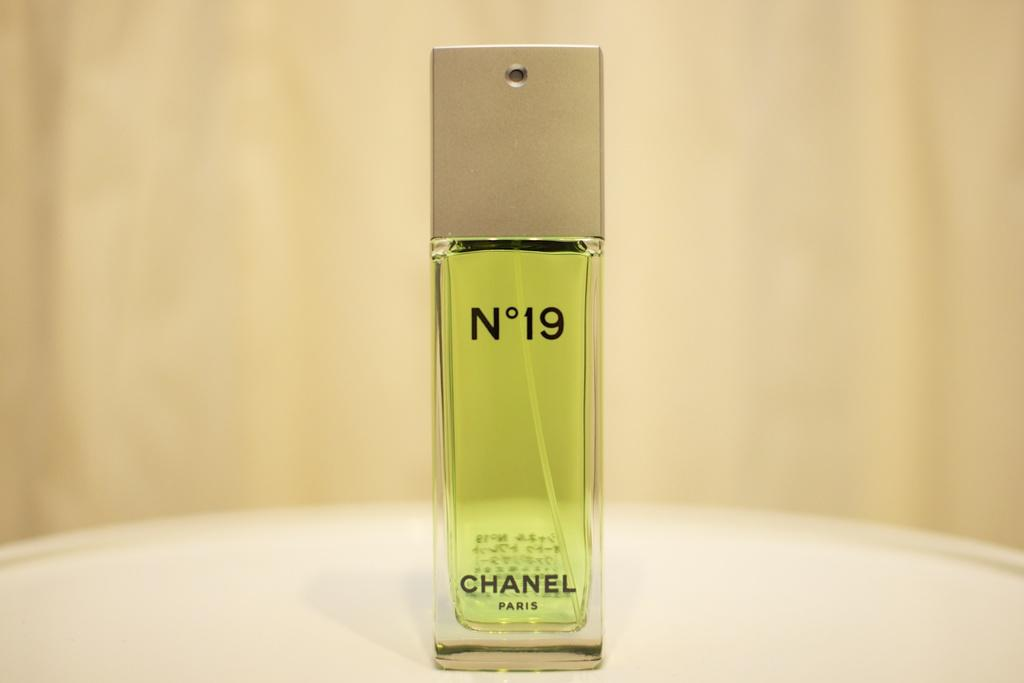<image>
Render a clear and concise summary of the photo. A full bottle of Chanel No 19 stands on a table with non English words on the back of the bottle. 